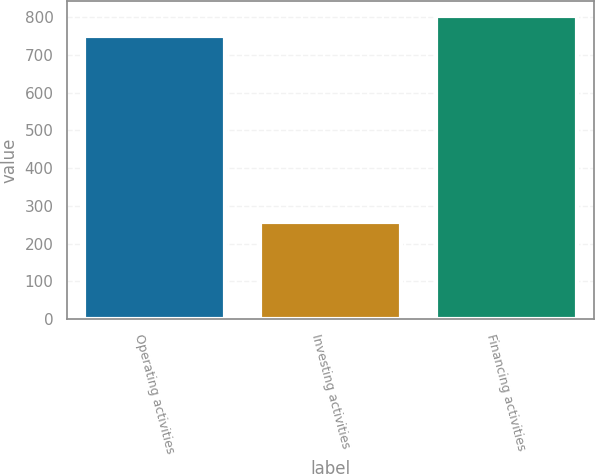Convert chart to OTSL. <chart><loc_0><loc_0><loc_500><loc_500><bar_chart><fcel>Operating activities<fcel>Investing activities<fcel>Financing activities<nl><fcel>750<fcel>258<fcel>801.7<nl></chart> 